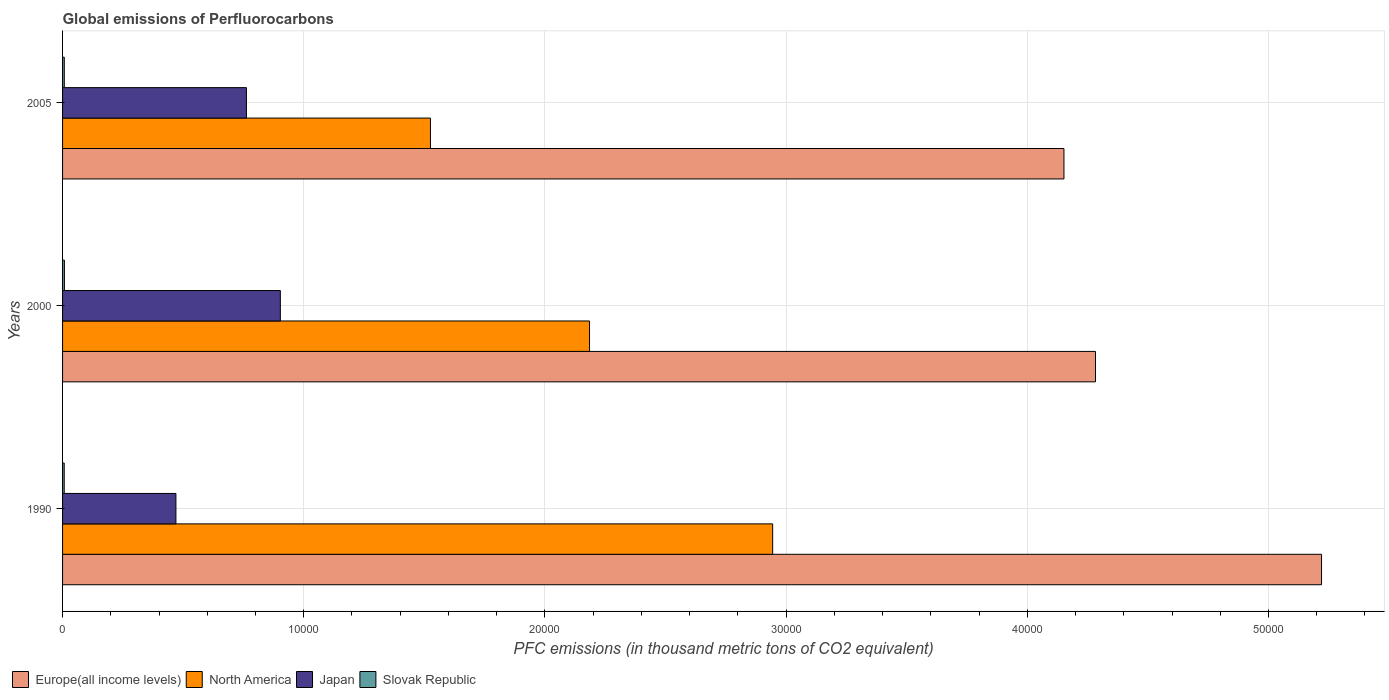How many different coloured bars are there?
Keep it short and to the point. 4. How many groups of bars are there?
Offer a very short reply. 3. Are the number of bars per tick equal to the number of legend labels?
Keep it short and to the point. Yes. How many bars are there on the 2nd tick from the bottom?
Provide a succinct answer. 4. What is the label of the 1st group of bars from the top?
Make the answer very short. 2005. What is the global emissions of Perfluorocarbons in Japan in 1990?
Your answer should be very brief. 4700. Across all years, what is the maximum global emissions of Perfluorocarbons in North America?
Offer a terse response. 2.94e+04. Across all years, what is the minimum global emissions of Perfluorocarbons in Japan?
Provide a short and direct response. 4700. In which year was the global emissions of Perfluorocarbons in Europe(all income levels) maximum?
Your answer should be very brief. 1990. What is the total global emissions of Perfluorocarbons in North America in the graph?
Provide a succinct answer. 6.65e+04. What is the difference between the global emissions of Perfluorocarbons in Slovak Republic in 2000 and that in 2005?
Your answer should be compact. 4.7. What is the difference between the global emissions of Perfluorocarbons in North America in 1990 and the global emissions of Perfluorocarbons in Japan in 2000?
Make the answer very short. 2.04e+04. What is the average global emissions of Perfluorocarbons in North America per year?
Your answer should be compact. 2.22e+04. In the year 2000, what is the difference between the global emissions of Perfluorocarbons in Japan and global emissions of Perfluorocarbons in Europe(all income levels)?
Offer a terse response. -3.38e+04. In how many years, is the global emissions of Perfluorocarbons in North America greater than 36000 thousand metric tons?
Offer a terse response. 0. What is the ratio of the global emissions of Perfluorocarbons in North America in 2000 to that in 2005?
Give a very brief answer. 1.43. Is the difference between the global emissions of Perfluorocarbons in Japan in 1990 and 2000 greater than the difference between the global emissions of Perfluorocarbons in Europe(all income levels) in 1990 and 2000?
Give a very brief answer. No. What is the difference between the highest and the second highest global emissions of Perfluorocarbons in Slovak Republic?
Provide a succinct answer. 4.7. What is the difference between the highest and the lowest global emissions of Perfluorocarbons in Japan?
Offer a terse response. 4329.8. In how many years, is the global emissions of Perfluorocarbons in Slovak Republic greater than the average global emissions of Perfluorocarbons in Slovak Republic taken over all years?
Your response must be concise. 1. Is it the case that in every year, the sum of the global emissions of Perfluorocarbons in Europe(all income levels) and global emissions of Perfluorocarbons in North America is greater than the sum of global emissions of Perfluorocarbons in Slovak Republic and global emissions of Perfluorocarbons in Japan?
Give a very brief answer. No. What does the 4th bar from the top in 1990 represents?
Your response must be concise. Europe(all income levels). Is it the case that in every year, the sum of the global emissions of Perfluorocarbons in Europe(all income levels) and global emissions of Perfluorocarbons in Slovak Republic is greater than the global emissions of Perfluorocarbons in Japan?
Provide a short and direct response. Yes. How many bars are there?
Keep it short and to the point. 12. Are all the bars in the graph horizontal?
Give a very brief answer. Yes. Where does the legend appear in the graph?
Provide a succinct answer. Bottom left. How are the legend labels stacked?
Your answer should be very brief. Horizontal. What is the title of the graph?
Make the answer very short. Global emissions of Perfluorocarbons. Does "Tonga" appear as one of the legend labels in the graph?
Make the answer very short. No. What is the label or title of the X-axis?
Your response must be concise. PFC emissions (in thousand metric tons of CO2 equivalent). What is the label or title of the Y-axis?
Offer a terse response. Years. What is the PFC emissions (in thousand metric tons of CO2 equivalent) in Europe(all income levels) in 1990?
Offer a very short reply. 5.22e+04. What is the PFC emissions (in thousand metric tons of CO2 equivalent) of North America in 1990?
Ensure brevity in your answer.  2.94e+04. What is the PFC emissions (in thousand metric tons of CO2 equivalent) in Japan in 1990?
Make the answer very short. 4700. What is the PFC emissions (in thousand metric tons of CO2 equivalent) of Slovak Republic in 1990?
Your response must be concise. 68.3. What is the PFC emissions (in thousand metric tons of CO2 equivalent) of Europe(all income levels) in 2000?
Provide a succinct answer. 4.28e+04. What is the PFC emissions (in thousand metric tons of CO2 equivalent) of North America in 2000?
Provide a succinct answer. 2.18e+04. What is the PFC emissions (in thousand metric tons of CO2 equivalent) in Japan in 2000?
Make the answer very short. 9029.8. What is the PFC emissions (in thousand metric tons of CO2 equivalent) of Slovak Republic in 2000?
Your answer should be compact. 76.3. What is the PFC emissions (in thousand metric tons of CO2 equivalent) of Europe(all income levels) in 2005?
Give a very brief answer. 4.15e+04. What is the PFC emissions (in thousand metric tons of CO2 equivalent) in North America in 2005?
Your response must be concise. 1.53e+04. What is the PFC emissions (in thousand metric tons of CO2 equivalent) of Japan in 2005?
Keep it short and to the point. 7623.6. What is the PFC emissions (in thousand metric tons of CO2 equivalent) in Slovak Republic in 2005?
Provide a succinct answer. 71.6. Across all years, what is the maximum PFC emissions (in thousand metric tons of CO2 equivalent) of Europe(all income levels)?
Offer a terse response. 5.22e+04. Across all years, what is the maximum PFC emissions (in thousand metric tons of CO2 equivalent) in North America?
Provide a succinct answer. 2.94e+04. Across all years, what is the maximum PFC emissions (in thousand metric tons of CO2 equivalent) in Japan?
Your answer should be very brief. 9029.8. Across all years, what is the maximum PFC emissions (in thousand metric tons of CO2 equivalent) of Slovak Republic?
Ensure brevity in your answer.  76.3. Across all years, what is the minimum PFC emissions (in thousand metric tons of CO2 equivalent) in Europe(all income levels)?
Keep it short and to the point. 4.15e+04. Across all years, what is the minimum PFC emissions (in thousand metric tons of CO2 equivalent) of North America?
Provide a short and direct response. 1.53e+04. Across all years, what is the minimum PFC emissions (in thousand metric tons of CO2 equivalent) in Japan?
Ensure brevity in your answer.  4700. Across all years, what is the minimum PFC emissions (in thousand metric tons of CO2 equivalent) in Slovak Republic?
Your answer should be very brief. 68.3. What is the total PFC emissions (in thousand metric tons of CO2 equivalent) in Europe(all income levels) in the graph?
Provide a succinct answer. 1.37e+05. What is the total PFC emissions (in thousand metric tons of CO2 equivalent) in North America in the graph?
Provide a short and direct response. 6.65e+04. What is the total PFC emissions (in thousand metric tons of CO2 equivalent) of Japan in the graph?
Offer a terse response. 2.14e+04. What is the total PFC emissions (in thousand metric tons of CO2 equivalent) of Slovak Republic in the graph?
Give a very brief answer. 216.2. What is the difference between the PFC emissions (in thousand metric tons of CO2 equivalent) in Europe(all income levels) in 1990 and that in 2000?
Your answer should be compact. 9372.1. What is the difference between the PFC emissions (in thousand metric tons of CO2 equivalent) of North America in 1990 and that in 2000?
Offer a terse response. 7592.7. What is the difference between the PFC emissions (in thousand metric tons of CO2 equivalent) of Japan in 1990 and that in 2000?
Provide a short and direct response. -4329.8. What is the difference between the PFC emissions (in thousand metric tons of CO2 equivalent) in Slovak Republic in 1990 and that in 2000?
Make the answer very short. -8. What is the difference between the PFC emissions (in thousand metric tons of CO2 equivalent) in Europe(all income levels) in 1990 and that in 2005?
Make the answer very short. 1.07e+04. What is the difference between the PFC emissions (in thousand metric tons of CO2 equivalent) of North America in 1990 and that in 2005?
Keep it short and to the point. 1.42e+04. What is the difference between the PFC emissions (in thousand metric tons of CO2 equivalent) of Japan in 1990 and that in 2005?
Your response must be concise. -2923.6. What is the difference between the PFC emissions (in thousand metric tons of CO2 equivalent) of Europe(all income levels) in 2000 and that in 2005?
Offer a very short reply. 1308.31. What is the difference between the PFC emissions (in thousand metric tons of CO2 equivalent) in North America in 2000 and that in 2005?
Make the answer very short. 6595.81. What is the difference between the PFC emissions (in thousand metric tons of CO2 equivalent) in Japan in 2000 and that in 2005?
Your answer should be compact. 1406.2. What is the difference between the PFC emissions (in thousand metric tons of CO2 equivalent) in Europe(all income levels) in 1990 and the PFC emissions (in thousand metric tons of CO2 equivalent) in North America in 2000?
Offer a very short reply. 3.04e+04. What is the difference between the PFC emissions (in thousand metric tons of CO2 equivalent) in Europe(all income levels) in 1990 and the PFC emissions (in thousand metric tons of CO2 equivalent) in Japan in 2000?
Provide a succinct answer. 4.32e+04. What is the difference between the PFC emissions (in thousand metric tons of CO2 equivalent) of Europe(all income levels) in 1990 and the PFC emissions (in thousand metric tons of CO2 equivalent) of Slovak Republic in 2000?
Keep it short and to the point. 5.21e+04. What is the difference between the PFC emissions (in thousand metric tons of CO2 equivalent) of North America in 1990 and the PFC emissions (in thousand metric tons of CO2 equivalent) of Japan in 2000?
Provide a short and direct response. 2.04e+04. What is the difference between the PFC emissions (in thousand metric tons of CO2 equivalent) of North America in 1990 and the PFC emissions (in thousand metric tons of CO2 equivalent) of Slovak Republic in 2000?
Your response must be concise. 2.94e+04. What is the difference between the PFC emissions (in thousand metric tons of CO2 equivalent) in Japan in 1990 and the PFC emissions (in thousand metric tons of CO2 equivalent) in Slovak Republic in 2000?
Keep it short and to the point. 4623.7. What is the difference between the PFC emissions (in thousand metric tons of CO2 equivalent) of Europe(all income levels) in 1990 and the PFC emissions (in thousand metric tons of CO2 equivalent) of North America in 2005?
Your answer should be compact. 3.69e+04. What is the difference between the PFC emissions (in thousand metric tons of CO2 equivalent) in Europe(all income levels) in 1990 and the PFC emissions (in thousand metric tons of CO2 equivalent) in Japan in 2005?
Your response must be concise. 4.46e+04. What is the difference between the PFC emissions (in thousand metric tons of CO2 equivalent) in Europe(all income levels) in 1990 and the PFC emissions (in thousand metric tons of CO2 equivalent) in Slovak Republic in 2005?
Give a very brief answer. 5.21e+04. What is the difference between the PFC emissions (in thousand metric tons of CO2 equivalent) of North America in 1990 and the PFC emissions (in thousand metric tons of CO2 equivalent) of Japan in 2005?
Ensure brevity in your answer.  2.18e+04. What is the difference between the PFC emissions (in thousand metric tons of CO2 equivalent) of North America in 1990 and the PFC emissions (in thousand metric tons of CO2 equivalent) of Slovak Republic in 2005?
Your answer should be compact. 2.94e+04. What is the difference between the PFC emissions (in thousand metric tons of CO2 equivalent) of Japan in 1990 and the PFC emissions (in thousand metric tons of CO2 equivalent) of Slovak Republic in 2005?
Provide a succinct answer. 4628.4. What is the difference between the PFC emissions (in thousand metric tons of CO2 equivalent) in Europe(all income levels) in 2000 and the PFC emissions (in thousand metric tons of CO2 equivalent) in North America in 2005?
Keep it short and to the point. 2.76e+04. What is the difference between the PFC emissions (in thousand metric tons of CO2 equivalent) in Europe(all income levels) in 2000 and the PFC emissions (in thousand metric tons of CO2 equivalent) in Japan in 2005?
Provide a short and direct response. 3.52e+04. What is the difference between the PFC emissions (in thousand metric tons of CO2 equivalent) of Europe(all income levels) in 2000 and the PFC emissions (in thousand metric tons of CO2 equivalent) of Slovak Republic in 2005?
Offer a terse response. 4.28e+04. What is the difference between the PFC emissions (in thousand metric tons of CO2 equivalent) of North America in 2000 and the PFC emissions (in thousand metric tons of CO2 equivalent) of Japan in 2005?
Make the answer very short. 1.42e+04. What is the difference between the PFC emissions (in thousand metric tons of CO2 equivalent) in North America in 2000 and the PFC emissions (in thousand metric tons of CO2 equivalent) in Slovak Republic in 2005?
Your response must be concise. 2.18e+04. What is the difference between the PFC emissions (in thousand metric tons of CO2 equivalent) of Japan in 2000 and the PFC emissions (in thousand metric tons of CO2 equivalent) of Slovak Republic in 2005?
Offer a very short reply. 8958.2. What is the average PFC emissions (in thousand metric tons of CO2 equivalent) of Europe(all income levels) per year?
Provide a short and direct response. 4.55e+04. What is the average PFC emissions (in thousand metric tons of CO2 equivalent) in North America per year?
Your answer should be compact. 2.22e+04. What is the average PFC emissions (in thousand metric tons of CO2 equivalent) of Japan per year?
Your answer should be compact. 7117.8. What is the average PFC emissions (in thousand metric tons of CO2 equivalent) in Slovak Republic per year?
Ensure brevity in your answer.  72.07. In the year 1990, what is the difference between the PFC emissions (in thousand metric tons of CO2 equivalent) in Europe(all income levels) and PFC emissions (in thousand metric tons of CO2 equivalent) in North America?
Ensure brevity in your answer.  2.28e+04. In the year 1990, what is the difference between the PFC emissions (in thousand metric tons of CO2 equivalent) in Europe(all income levels) and PFC emissions (in thousand metric tons of CO2 equivalent) in Japan?
Offer a terse response. 4.75e+04. In the year 1990, what is the difference between the PFC emissions (in thousand metric tons of CO2 equivalent) of Europe(all income levels) and PFC emissions (in thousand metric tons of CO2 equivalent) of Slovak Republic?
Ensure brevity in your answer.  5.21e+04. In the year 1990, what is the difference between the PFC emissions (in thousand metric tons of CO2 equivalent) in North America and PFC emissions (in thousand metric tons of CO2 equivalent) in Japan?
Your answer should be compact. 2.47e+04. In the year 1990, what is the difference between the PFC emissions (in thousand metric tons of CO2 equivalent) in North America and PFC emissions (in thousand metric tons of CO2 equivalent) in Slovak Republic?
Keep it short and to the point. 2.94e+04. In the year 1990, what is the difference between the PFC emissions (in thousand metric tons of CO2 equivalent) in Japan and PFC emissions (in thousand metric tons of CO2 equivalent) in Slovak Republic?
Your answer should be very brief. 4631.7. In the year 2000, what is the difference between the PFC emissions (in thousand metric tons of CO2 equivalent) of Europe(all income levels) and PFC emissions (in thousand metric tons of CO2 equivalent) of North America?
Provide a succinct answer. 2.10e+04. In the year 2000, what is the difference between the PFC emissions (in thousand metric tons of CO2 equivalent) of Europe(all income levels) and PFC emissions (in thousand metric tons of CO2 equivalent) of Japan?
Offer a very short reply. 3.38e+04. In the year 2000, what is the difference between the PFC emissions (in thousand metric tons of CO2 equivalent) in Europe(all income levels) and PFC emissions (in thousand metric tons of CO2 equivalent) in Slovak Republic?
Provide a succinct answer. 4.28e+04. In the year 2000, what is the difference between the PFC emissions (in thousand metric tons of CO2 equivalent) in North America and PFC emissions (in thousand metric tons of CO2 equivalent) in Japan?
Give a very brief answer. 1.28e+04. In the year 2000, what is the difference between the PFC emissions (in thousand metric tons of CO2 equivalent) in North America and PFC emissions (in thousand metric tons of CO2 equivalent) in Slovak Republic?
Your answer should be compact. 2.18e+04. In the year 2000, what is the difference between the PFC emissions (in thousand metric tons of CO2 equivalent) of Japan and PFC emissions (in thousand metric tons of CO2 equivalent) of Slovak Republic?
Keep it short and to the point. 8953.5. In the year 2005, what is the difference between the PFC emissions (in thousand metric tons of CO2 equivalent) in Europe(all income levels) and PFC emissions (in thousand metric tons of CO2 equivalent) in North America?
Make the answer very short. 2.63e+04. In the year 2005, what is the difference between the PFC emissions (in thousand metric tons of CO2 equivalent) in Europe(all income levels) and PFC emissions (in thousand metric tons of CO2 equivalent) in Japan?
Give a very brief answer. 3.39e+04. In the year 2005, what is the difference between the PFC emissions (in thousand metric tons of CO2 equivalent) in Europe(all income levels) and PFC emissions (in thousand metric tons of CO2 equivalent) in Slovak Republic?
Your answer should be compact. 4.14e+04. In the year 2005, what is the difference between the PFC emissions (in thousand metric tons of CO2 equivalent) of North America and PFC emissions (in thousand metric tons of CO2 equivalent) of Japan?
Provide a short and direct response. 7629.49. In the year 2005, what is the difference between the PFC emissions (in thousand metric tons of CO2 equivalent) of North America and PFC emissions (in thousand metric tons of CO2 equivalent) of Slovak Republic?
Offer a terse response. 1.52e+04. In the year 2005, what is the difference between the PFC emissions (in thousand metric tons of CO2 equivalent) of Japan and PFC emissions (in thousand metric tons of CO2 equivalent) of Slovak Republic?
Give a very brief answer. 7552. What is the ratio of the PFC emissions (in thousand metric tons of CO2 equivalent) of Europe(all income levels) in 1990 to that in 2000?
Keep it short and to the point. 1.22. What is the ratio of the PFC emissions (in thousand metric tons of CO2 equivalent) in North America in 1990 to that in 2000?
Offer a terse response. 1.35. What is the ratio of the PFC emissions (in thousand metric tons of CO2 equivalent) of Japan in 1990 to that in 2000?
Your answer should be very brief. 0.52. What is the ratio of the PFC emissions (in thousand metric tons of CO2 equivalent) of Slovak Republic in 1990 to that in 2000?
Ensure brevity in your answer.  0.9. What is the ratio of the PFC emissions (in thousand metric tons of CO2 equivalent) of Europe(all income levels) in 1990 to that in 2005?
Make the answer very short. 1.26. What is the ratio of the PFC emissions (in thousand metric tons of CO2 equivalent) in North America in 1990 to that in 2005?
Make the answer very short. 1.93. What is the ratio of the PFC emissions (in thousand metric tons of CO2 equivalent) in Japan in 1990 to that in 2005?
Your answer should be compact. 0.62. What is the ratio of the PFC emissions (in thousand metric tons of CO2 equivalent) in Slovak Republic in 1990 to that in 2005?
Your response must be concise. 0.95. What is the ratio of the PFC emissions (in thousand metric tons of CO2 equivalent) of Europe(all income levels) in 2000 to that in 2005?
Ensure brevity in your answer.  1.03. What is the ratio of the PFC emissions (in thousand metric tons of CO2 equivalent) of North America in 2000 to that in 2005?
Your answer should be compact. 1.43. What is the ratio of the PFC emissions (in thousand metric tons of CO2 equivalent) in Japan in 2000 to that in 2005?
Provide a short and direct response. 1.18. What is the ratio of the PFC emissions (in thousand metric tons of CO2 equivalent) in Slovak Republic in 2000 to that in 2005?
Keep it short and to the point. 1.07. What is the difference between the highest and the second highest PFC emissions (in thousand metric tons of CO2 equivalent) of Europe(all income levels)?
Make the answer very short. 9372.1. What is the difference between the highest and the second highest PFC emissions (in thousand metric tons of CO2 equivalent) in North America?
Offer a terse response. 7592.7. What is the difference between the highest and the second highest PFC emissions (in thousand metric tons of CO2 equivalent) in Japan?
Your answer should be compact. 1406.2. What is the difference between the highest and the lowest PFC emissions (in thousand metric tons of CO2 equivalent) of Europe(all income levels)?
Provide a short and direct response. 1.07e+04. What is the difference between the highest and the lowest PFC emissions (in thousand metric tons of CO2 equivalent) in North America?
Offer a very short reply. 1.42e+04. What is the difference between the highest and the lowest PFC emissions (in thousand metric tons of CO2 equivalent) of Japan?
Keep it short and to the point. 4329.8. What is the difference between the highest and the lowest PFC emissions (in thousand metric tons of CO2 equivalent) of Slovak Republic?
Provide a short and direct response. 8. 